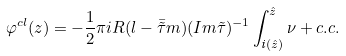<formula> <loc_0><loc_0><loc_500><loc_500>\varphi ^ { c l } ( z ) = - \frac { 1 } { 2 } \pi i R ( l - \bar { \tilde { \tau } } m ) ( I m \tilde { \tau } ) ^ { - 1 } \int _ { { \emph i } ( \hat { z } ) } ^ { \hat { z } } \nu + c . c .</formula> 